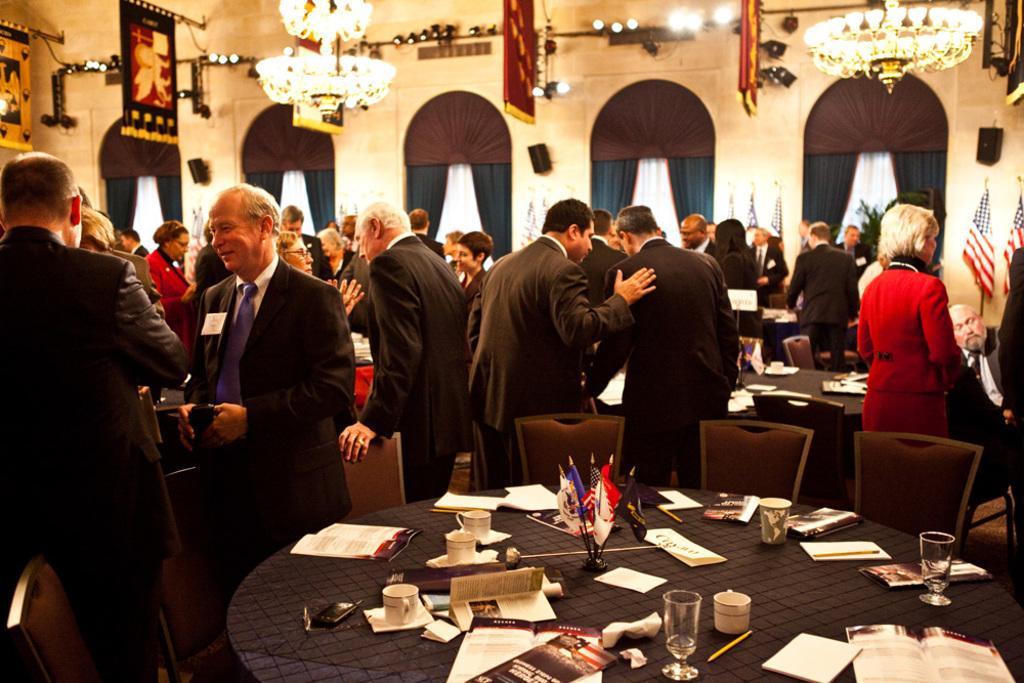Can you describe this image briefly? The image consist so many people and there are tables and chairs all around with books,coffee cups and flag and chandelier on the ceiling,this seems to be conference area. 